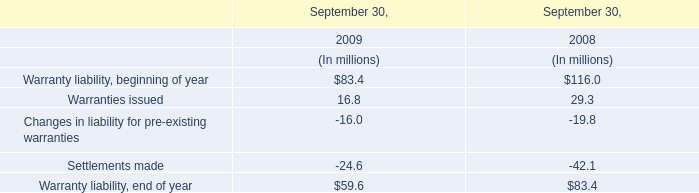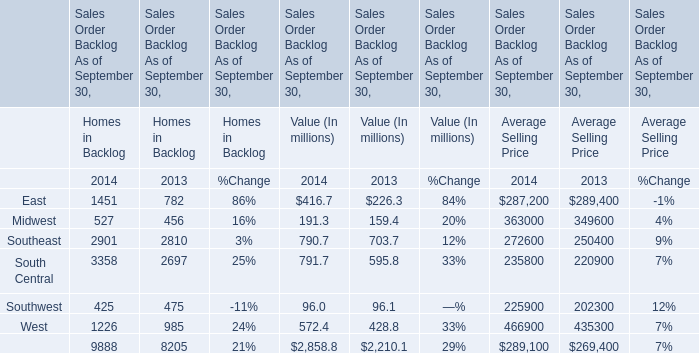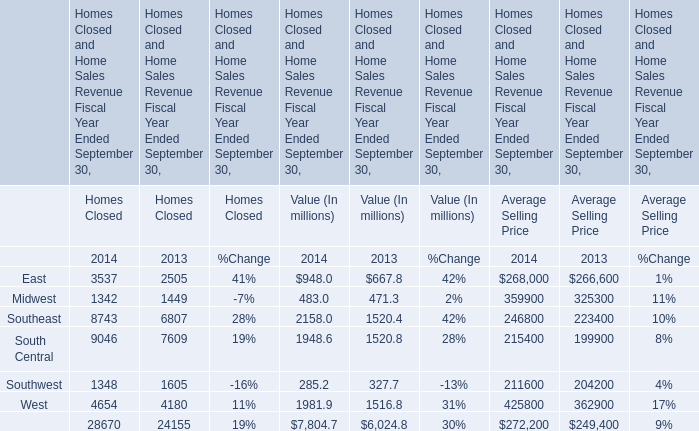assuming a fmv of a share equal to 2000 , under the pre-december 31 , 2007 plan , approximately how many shares would each non-employee director receive annually? 
Computations: (60000 / (2000 / 3))
Answer: 90.0. 